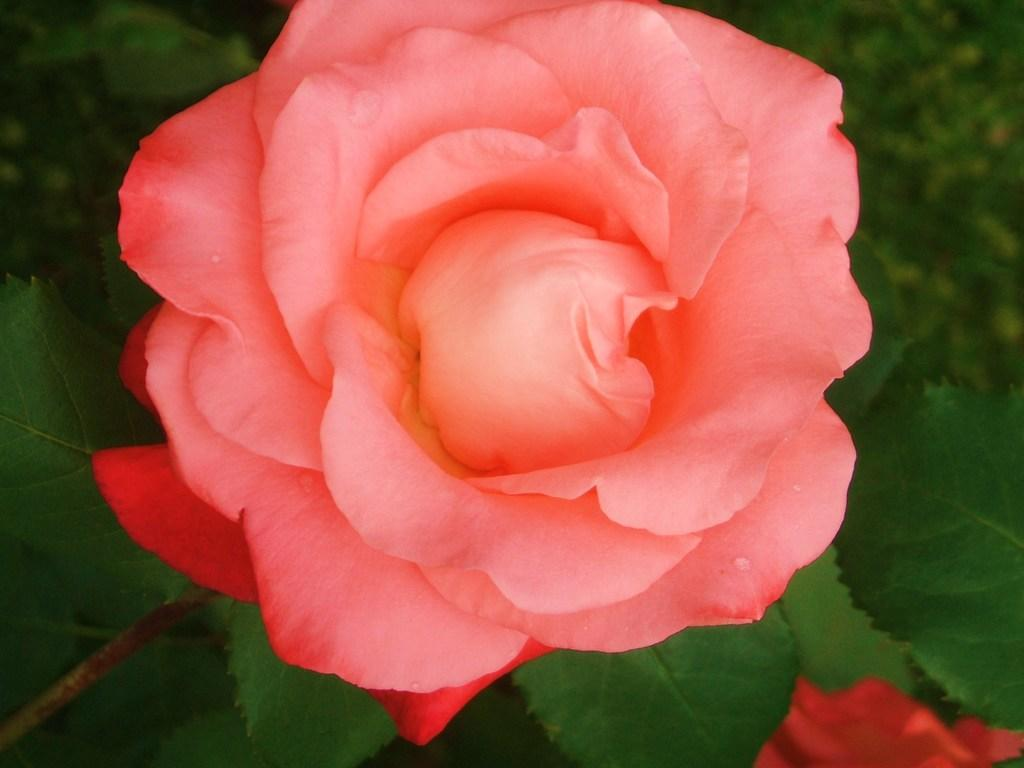What is the main subject of the image? There is a flower in the image. What else can be seen in the image besides the flower? There are leaves in the image. Can you describe the background of the image? The background of the image is blurred. What is the fastest route to the whip in the image? There is no whip present in the image. Where is the lunchroom located in the image? There is no lunchroom present in the image. 